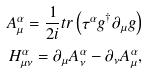<formula> <loc_0><loc_0><loc_500><loc_500>A _ { \mu } ^ { \alpha } = \frac { 1 } { 2 i } t r \left ( \tau ^ { \alpha } g ^ { \dagger } \partial _ { \mu } g \right ) \\ H _ { \mu \nu } ^ { \alpha } = \partial _ { \mu } A _ { \nu } ^ { \alpha } - \partial _ { \nu } A _ { \mu } ^ { \alpha } ,</formula> 